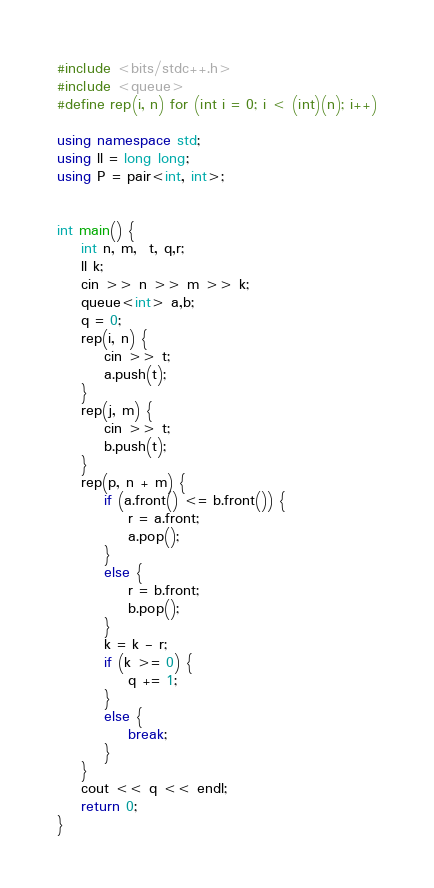Convert code to text. <code><loc_0><loc_0><loc_500><loc_500><_C++_>#include <bits/stdc++.h>
#include <queue>
#define rep(i, n) for (int i = 0; i < (int)(n); i++)

using namespace std;
using ll = long long;
using P = pair<int, int>;


int main() {
    int n, m,  t, q,r;
    ll k;
    cin >> n >> m >> k;
    queue<int> a,b;
    q = 0;
    rep(i, n) {
        cin >> t;
        a.push(t);
    }
    rep(j, m) {
        cin >> t;
        b.push(t);
    }
    rep(p, n + m) {
        if (a.front() <= b.front()) {
            r = a.front;
            a.pop();
        }
        else {
            r = b.front;
            b.pop();
        }
        k = k - r;
        if (k >= 0) {
            q += 1;
        }
        else {
            break;
        }
    }
    cout << q << endl;
	return 0;
}</code> 